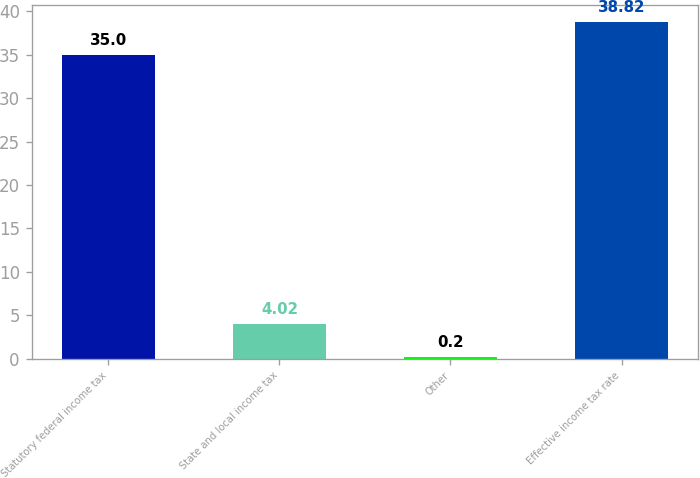Convert chart. <chart><loc_0><loc_0><loc_500><loc_500><bar_chart><fcel>Statutory federal income tax<fcel>State and local income tax<fcel>Other<fcel>Effective income tax rate<nl><fcel>35<fcel>4.02<fcel>0.2<fcel>38.82<nl></chart> 